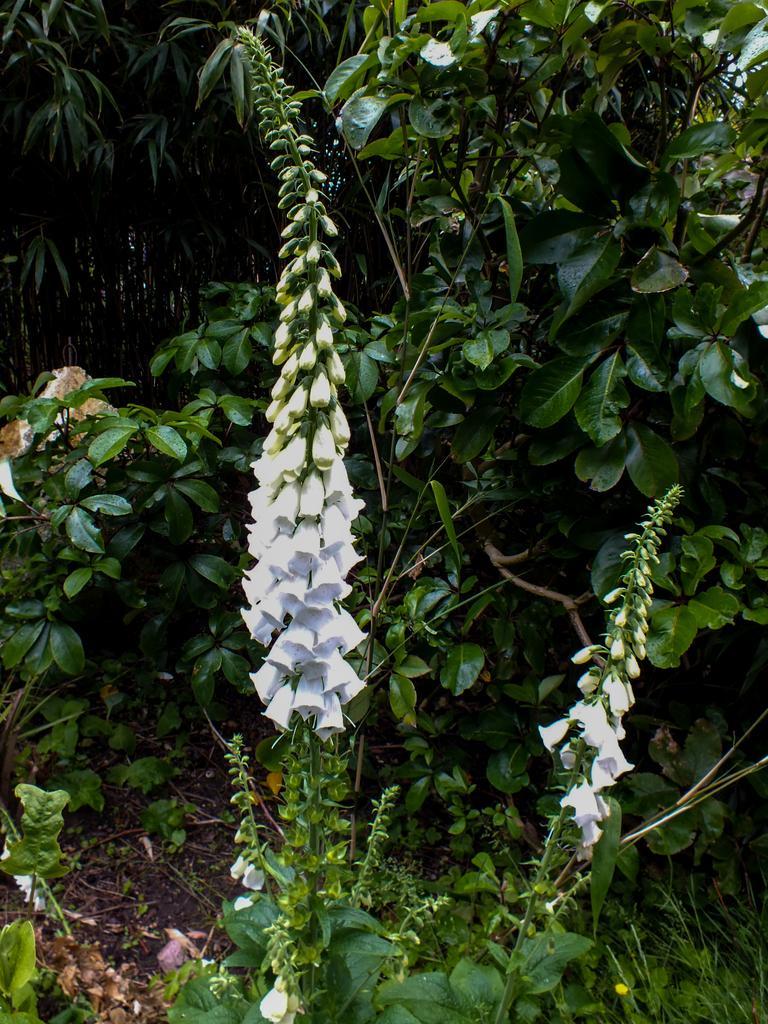Could you give a brief overview of what you see in this image? In this image there are many plants with green leaves, stems and flowers. This image is taken outdoors. At the bottom of the image there is a ground with grass on it and there are few dry leaves on the ground. 